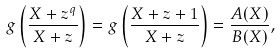<formula> <loc_0><loc_0><loc_500><loc_500>g \left ( \frac { X + z ^ { q } } { X + z } \right ) = g \left ( \frac { X + z + 1 } { X + z } \right ) = \frac { A ( X ) } { B ( X ) } ,</formula> 